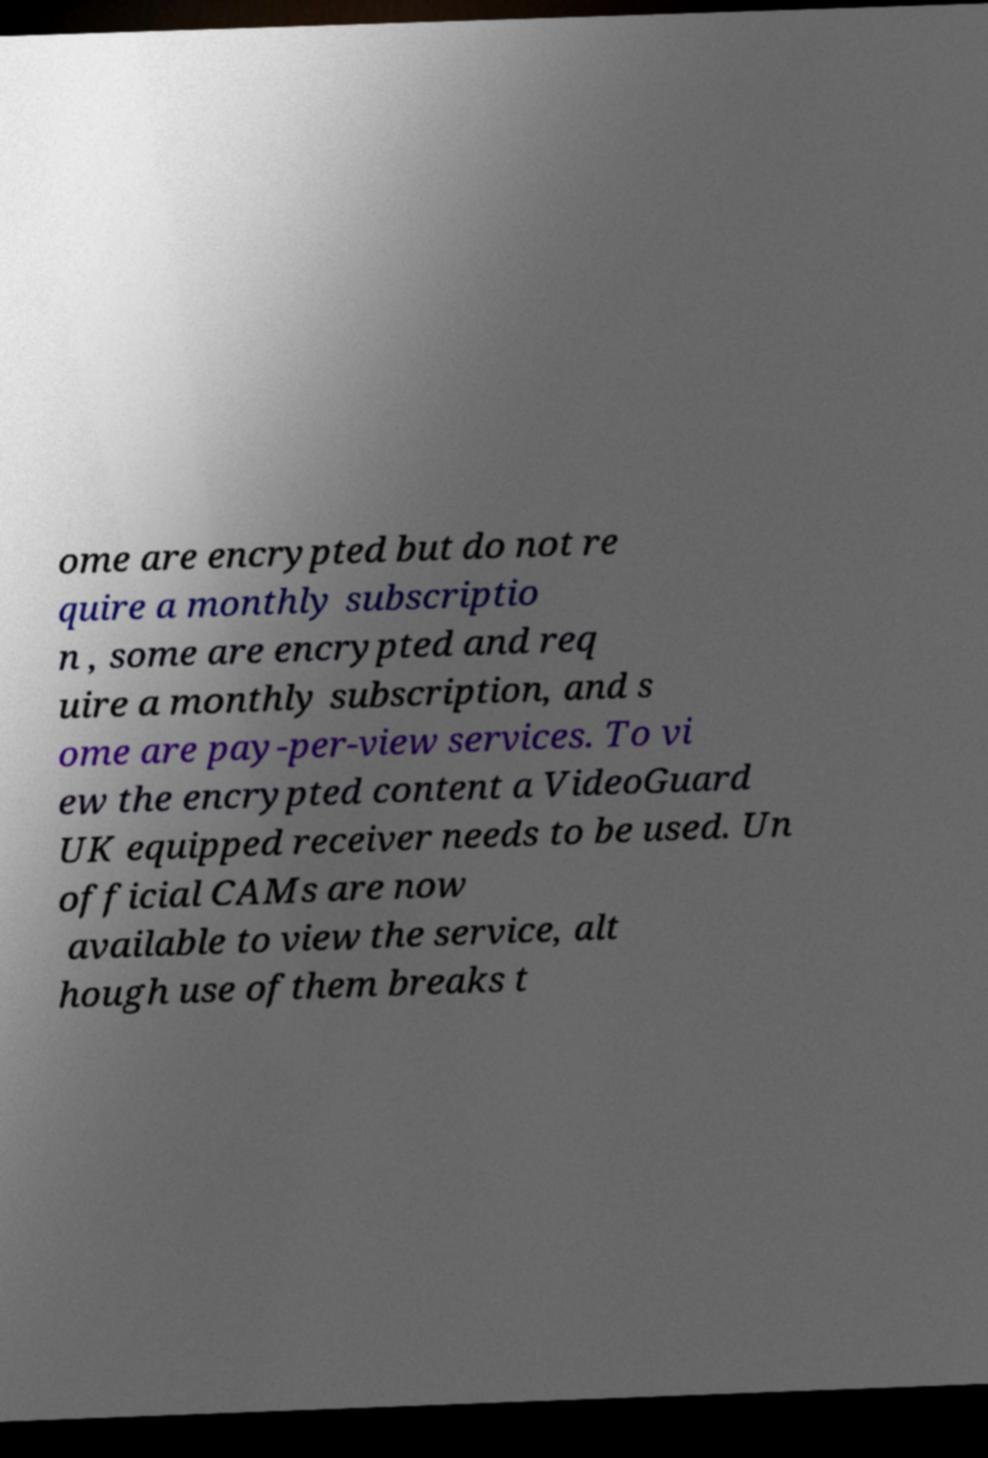Can you accurately transcribe the text from the provided image for me? ome are encrypted but do not re quire a monthly subscriptio n , some are encrypted and req uire a monthly subscription, and s ome are pay-per-view services. To vi ew the encrypted content a VideoGuard UK equipped receiver needs to be used. Un official CAMs are now available to view the service, alt hough use ofthem breaks t 